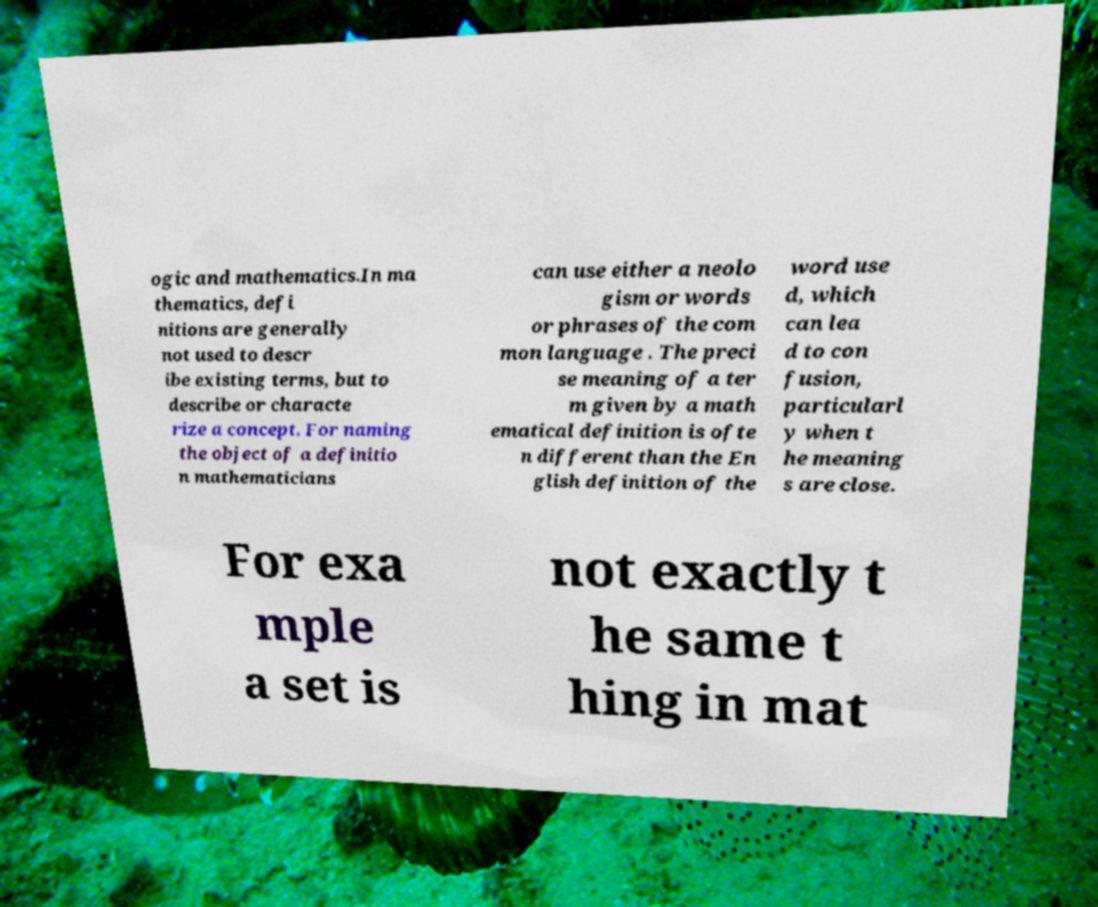Could you assist in decoding the text presented in this image and type it out clearly? ogic and mathematics.In ma thematics, defi nitions are generally not used to descr ibe existing terms, but to describe or characte rize a concept. For naming the object of a definitio n mathematicians can use either a neolo gism or words or phrases of the com mon language . The preci se meaning of a ter m given by a math ematical definition is ofte n different than the En glish definition of the word use d, which can lea d to con fusion, particularl y when t he meaning s are close. For exa mple a set is not exactly t he same t hing in mat 